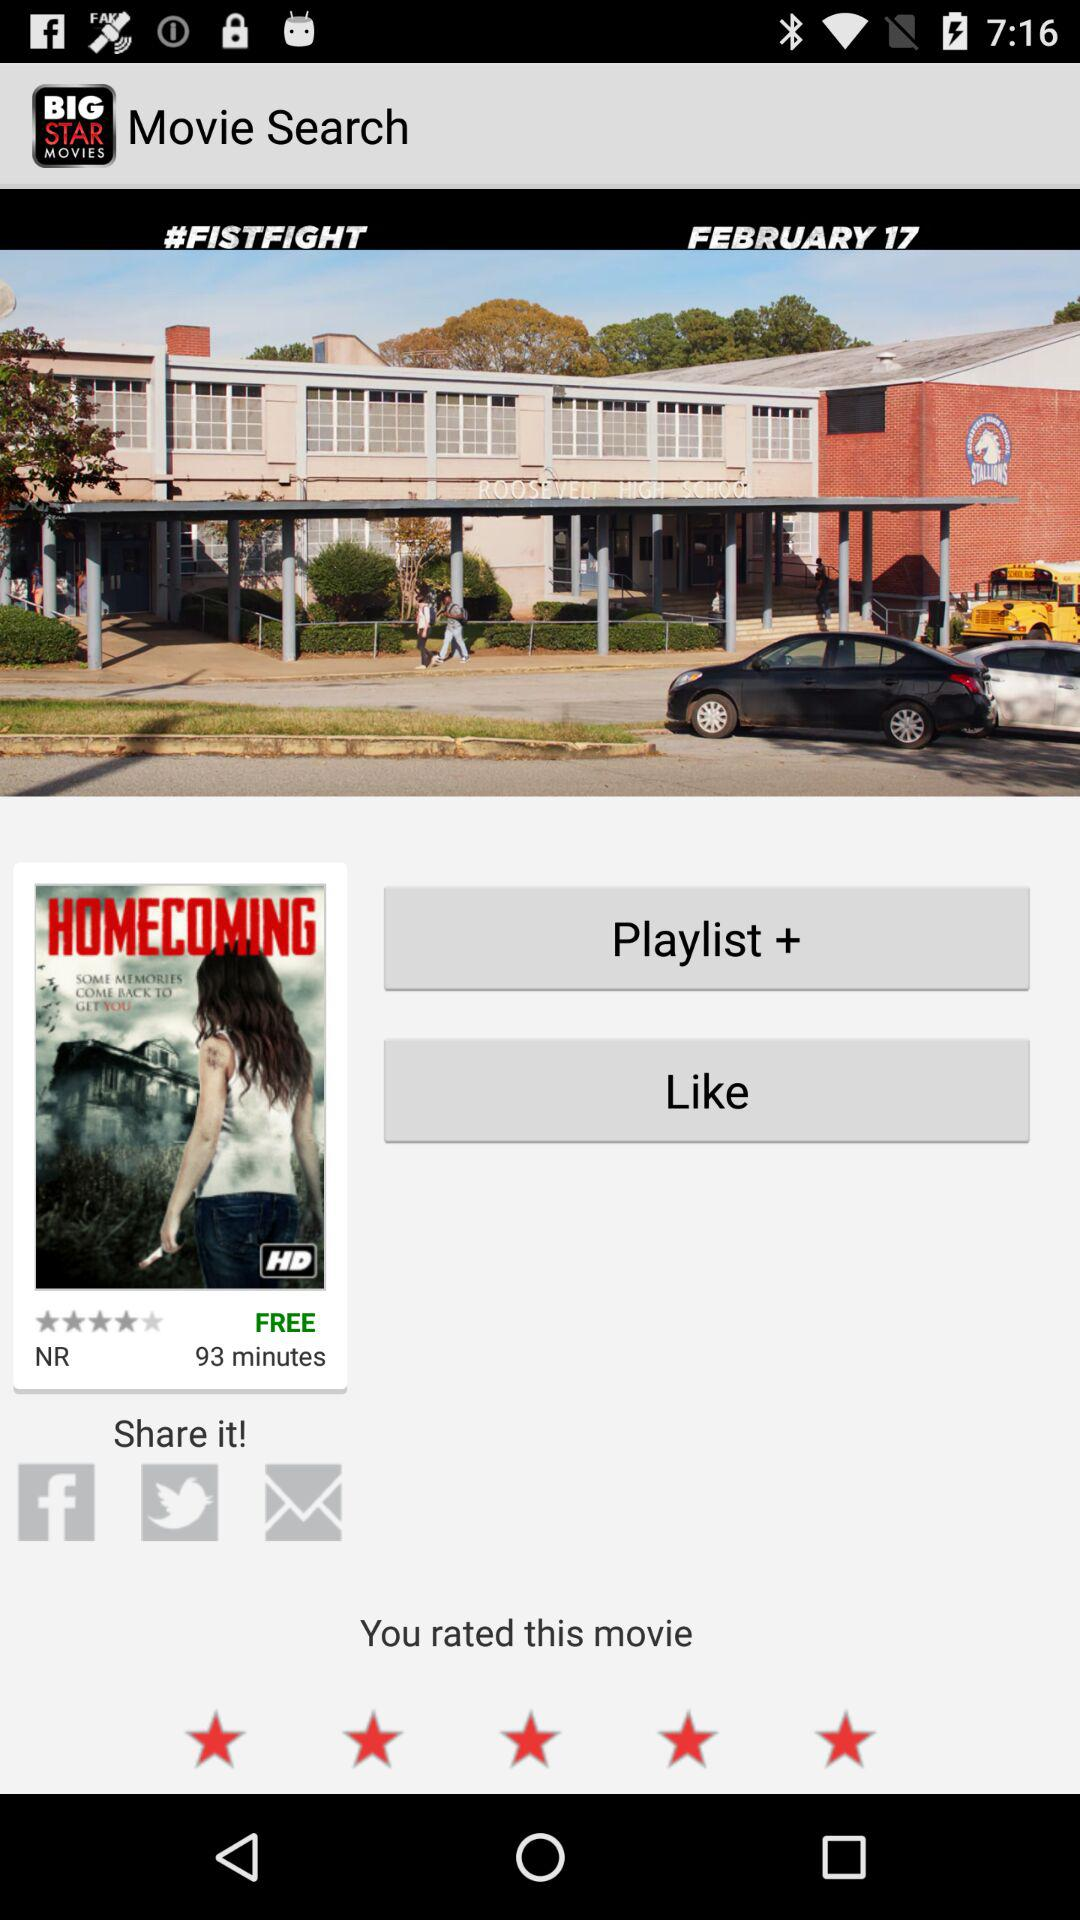What is the title of the movie? The titles of the movies are "FISTFIGHT" and "HOMECOMING". 